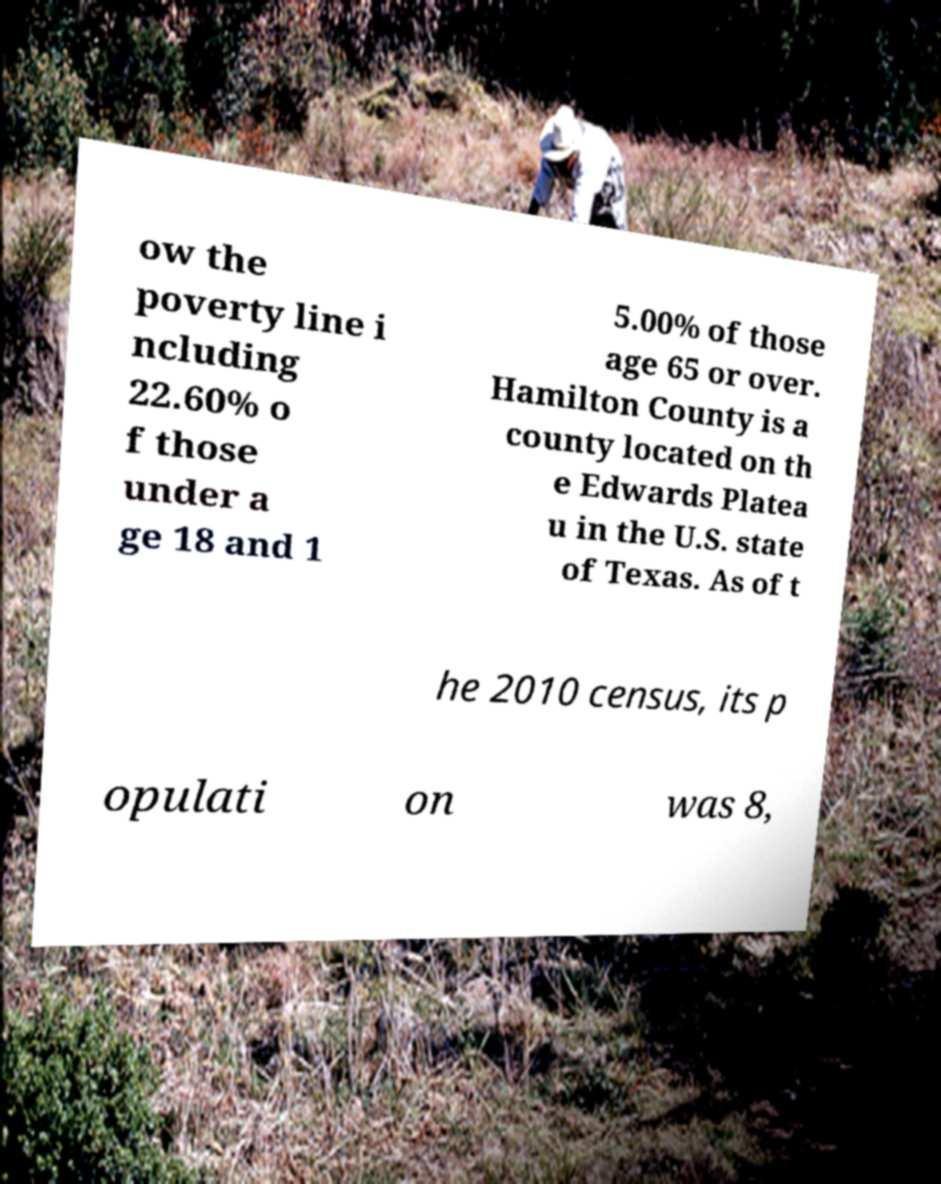Could you assist in decoding the text presented in this image and type it out clearly? ow the poverty line i ncluding 22.60% o f those under a ge 18 and 1 5.00% of those age 65 or over. Hamilton County is a county located on th e Edwards Platea u in the U.S. state of Texas. As of t he 2010 census, its p opulati on was 8, 